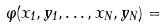Convert formula to latex. <formula><loc_0><loc_0><loc_500><loc_500>\varphi ( x _ { 1 } , y _ { 1 } , \dots , x _ { N } , y _ { N } ) =</formula> 